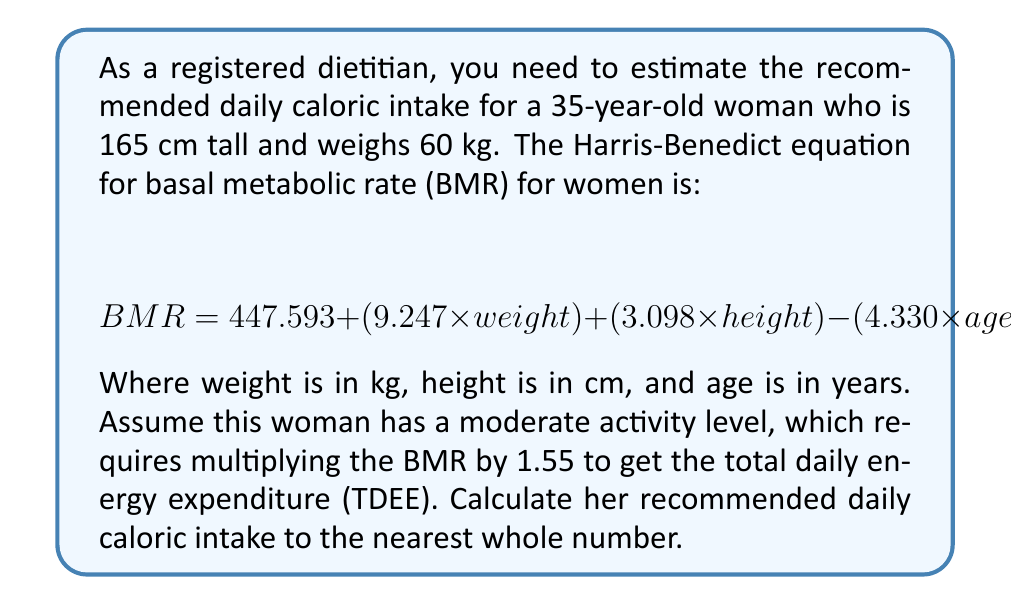Can you solve this math problem? To solve this problem, we'll follow these steps:

1. Input the given values into the Harris-Benedict equation:
   $$ BMR = 447.593 + (9.247 \times 60) + (3.098 \times 165) - (4.330 \times 35) $$

2. Calculate each term:
   $$ BMR = 447.593 + 554.82 + 511.17 - 151.55 $$

3. Sum up the terms to get the BMR:
   $$ BMR = 1362.033 \text{ calories} $$

4. Multiply the BMR by the activity factor (1.55) to get the TDEE:
   $$ TDEE = 1362.033 \times 1.55 = 2111.15115 \text{ calories} $$

5. Round to the nearest whole number:
   $$ TDEE \approx 2111 \text{ calories} $$

Therefore, the recommended daily caloric intake for this woman is approximately 2111 calories.
Answer: 2111 calories 